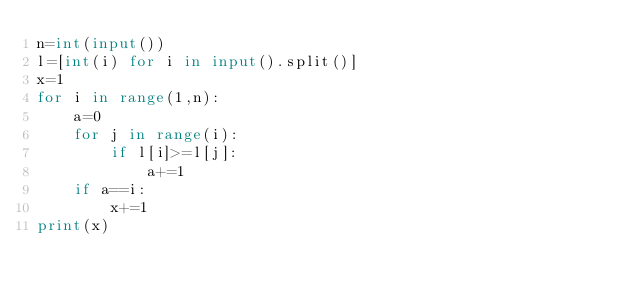<code> <loc_0><loc_0><loc_500><loc_500><_Python_>n=int(input())
l=[int(i) for i in input().split()]
x=1
for i in range(1,n):
    a=0
    for j in range(i):
        if l[i]>=l[j]:
            a+=1
    if a==i:
        x+=1
print(x)</code> 